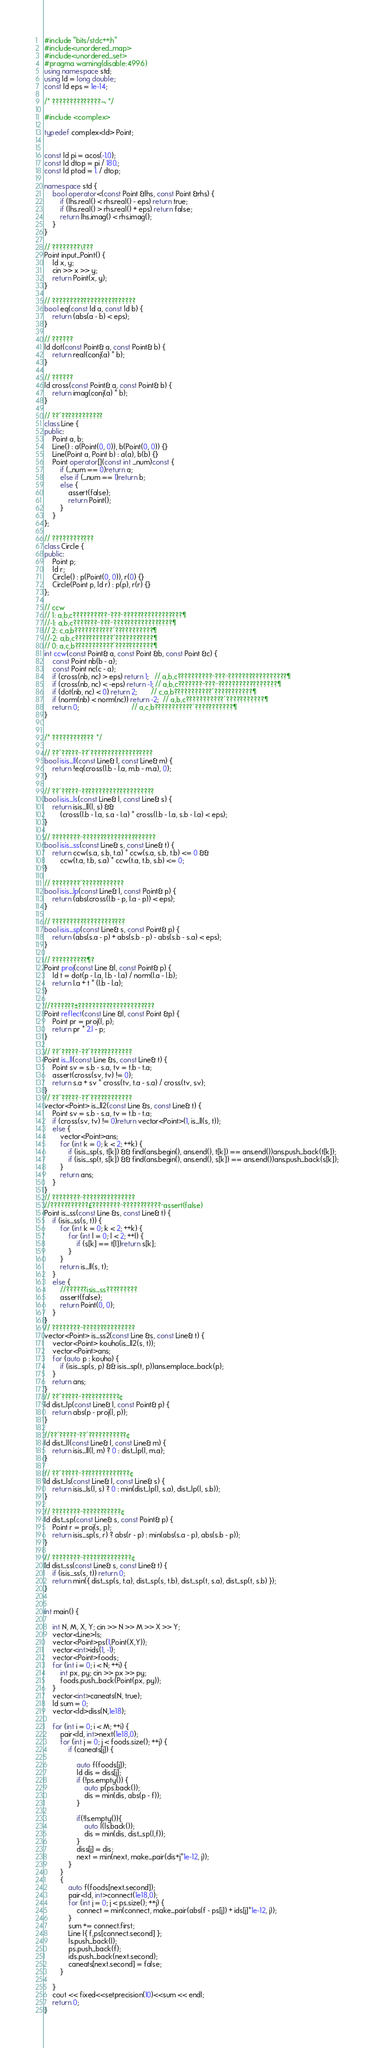Convert code to text. <code><loc_0><loc_0><loc_500><loc_500><_C++_>#include "bits/stdc++.h"
#include<unordered_map>
#include<unordered_set>
#pragma warning(disable:4996)
using namespace std;
using ld = long double;
const ld eps = 1e-14;

/* ??????????????¬ */

#include <complex>

typedef complex<ld> Point;


const ld pi = acos(-1.0);
const ld dtop = pi / 180.;
const ld ptod = 1. / dtop;

namespace std {
	bool operator<(const Point &lhs, const Point &rhs) {
		if (lhs.real() < rhs.real() - eps) return true;
		if (lhs.real() > rhs.real() + eps) return false;
		return lhs.imag() < rhs.imag();
	}
}

// ????????\???
Point input_Point() {
	ld x, y;
	cin >> x >> y;
	return Point(x, y);
}

// ????????????????????????
bool eq(const ld a, const ld b) {
	return (abs(a - b) < eps);
}

// ??????
ld dot(const Point& a, const Point& b) {
	return real(conj(a) * b);
}

// ??????
ld cross(const Point& a, const Point& b) {
	return imag(conj(a) * b);
}

// ??´????????????
class Line {
public:
	Point a, b;
	Line() : a(Point(0, 0)), b(Point(0, 0)) {}
	Line(Point a, Point b) : a(a), b(b) {}
	Point operator[](const int _num)const {
		if (_num == 0)return a;
		else if (_num == 1)return b;
		else {
			assert(false);
			return Point();
		}
	}
};

// ????????????
class Circle {
public:
	Point p;
	ld r;
	Circle() : p(Point(0, 0)), r(0) {}
	Circle(Point p, ld r) : p(p), r(r) {}
};

// ccw
// 1: a,b,c??????????¨???¨?????????????????¶
//-1: a,b,c???????¨???¨?????????????????¶
// 2: c,a,b???????????´???????????¶
//-2: a,b,c???????????´???????????¶
// 0: a,c,b???????????´???????????¶
int ccw(const Point& a, const Point &b, const Point &c) {
	const Point nb(b - a);
	const Point nc(c - a);
	if (cross(nb, nc) > eps) return 1;   // a,b,c??????????¨???¨?????????????????¶
	if (cross(nb, nc) < -eps) return -1; // a,b,c???????¨???¨?????????????????¶
	if (dot(nb, nc) < 0) return 2;       // c,a,b???????????´???????????¶
	if (norm(nb) < norm(nc)) return -2;  // a,b,c???????????´???????????¶
	return 0;                          // a,c,b???????????´???????????¶
}


/* ???????????? */

// ??´?????¨??´??????????????????
bool isis_ll(const Line& l, const Line& m) {
	return !eq(cross(l.b - l.a, m.b - m.a), 0);
}

// ??´?????¨?????????????????????
bool isis_ls(const Line& l, const Line& s) {
	return isis_ll(l, s) &&
		(cross(l.b - l.a, s.a - l.a) * cross(l.b - l.a, s.b - l.a) < eps);
}

// ????????¨?????????????????????
bool isis_ss(const Line& s, const Line& t) {
	return ccw(s.a, s.b, t.a) * ccw(s.a, s.b, t.b) <= 0 &&
		ccw(t.a, t.b, s.a) * ccw(t.a, t.b, s.b) <= 0;
}

// ????????´????????????
bool isis_lp(const Line& l, const Point& p) {
	return (abs(cross(l.b - p, l.a - p)) < eps);
}

// ?????????????????????
bool isis_sp(const Line& s, const Point& p) {
	return (abs(s.a - p) + abs(s.b - p) - abs(s.b - s.a) < eps);
}

// ??????????¶?
Point proj(const Line &l, const Point& p) {
	ld t = dot(p - l.a, l.b - l.a) / norm(l.a - l.b);
	return l.a + t * (l.b - l.a);
}

//???????±??????????????????????
Point reflect(const Line &l, const Point &p) {
	Point pr = proj(l, p);
	return pr * 2.l - p;
}

// ??´?????¨??´????????????
Point is_ll(const Line &s, const Line& t) {
	Point sv = s.b - s.a, tv = t.b - t.a;
	assert(cross(sv, tv) != 0);
	return s.a + sv * cross(tv, t.a - s.a) / cross(tv, sv);
}
// ??´?????¨??´????????????
vector<Point> is_ll2(const Line &s, const Line& t) {
	Point sv = s.b - s.a, tv = t.b - t.a;
	if (cross(sv, tv) != 0)return vector<Point>(1, is_ll(s, t));
	else {
		vector<Point>ans;
		for (int k = 0; k < 2; ++k) {
			if (isis_sp(s, t[k]) && find(ans.begin(), ans.end(), t[k]) == ans.end())ans.push_back(t[k]);
			if (isis_sp(t, s[k]) && find(ans.begin(), ans.end(), s[k]) == ans.end())ans.push_back(s[k]);
		}
		return ans;
	}
}
// ????????¨???????????????
//???????????£????????¨???????????¨assert(false)
Point is_ss(const Line &s, const Line& t) {
	if (isis_ss(s, t)) {
		for (int k = 0; k < 2; ++k) {
			for (int l = 0; l < 2; ++l) {
				if (s[k] == t[l])return s[k];
			}
		}
		return is_ll(s, t);
	}
	else {
		//??????isis_ss?????????
		assert(false);
		return Point(0, 0);
	}
}
// ????????¨???????????????
vector<Point> is_ss2(const Line &s, const Line& t) {
	vector<Point> kouho(is_ll2(s, t));
	vector<Point>ans;
	for (auto p : kouho) {
		if (isis_sp(s, p) && isis_sp(t, p))ans.emplace_back(p);
	}
	return ans;
}
// ??´?????¨???????????¢
ld dist_lp(const Line& l, const Point& p) {
	return abs(p - proj(l, p));
}

//??´?????¨??´???????????¢
ld dist_ll(const Line& l, const Line& m) {
	return isis_ll(l, m) ? 0 : dist_lp(l, m.a);
}

// ??´?????¨??????????????¢
ld dist_ls(const Line& l, const Line& s) {
	return isis_ls(l, s) ? 0 : min(dist_lp(l, s.a), dist_lp(l, s.b));
}

// ????????¨???????????¢
ld dist_sp(const Line& s, const Point& p) {
	Point r = proj(s, p);
	return isis_sp(s, r) ? abs(r - p) : min(abs(s.a - p), abs(s.b - p));
}

// ????????¨??????????????¢
ld dist_ss(const Line& s, const Line& t) {
	if (isis_ss(s, t)) return 0;
	return min({ dist_sp(s, t.a), dist_sp(s, t.b), dist_sp(t, s.a), dist_sp(t, s.b) });
}


int main() {
	
	int N, M, X, Y; cin >> N >> M >> X >> Y;
	vector<Line>ls;
	vector<Point>ps(1,Point(X,Y));
	vector<int>ids(1, -1);
	vector<Point>foods;
	for (int i = 0; i < N; ++i) {
		int px, py; cin >> px >> py;
		foods.push_back(Point(px, py));
	}
	vector<int>caneats(N, true);
	ld sum = 0;
	vector<ld>diss(N,1e18);

	for (int i = 0; i < M; ++i) {
		pair<ld, int>next(1e18,0);
		for (int j = 0; j < foods.size(); ++j) {
			if (caneats[j]) {

				auto f(foods[j]);
				ld dis = diss[j];
				if (!ps.empty()) {
					auto p(ps.back());
					dis = min(dis, abs(p - f));
				}
				
				if(!ls.empty()){
					auto l(ls.back());
					dis = min(dis, dist_sp(l,f));
				}
				diss[j] = dis;
				next = min(next, make_pair(dis+j*1e-12, j));
			}
		} 
		{
			auto f(foods[next.second]);
			pair<ld, int>connect(1e18,0);
			for (int j = 0; j < ps.size(); ++j) {
				connect = min(connect, make_pair(abs(f - ps[j]) + ids[j]*1e-12, j));
			}
			sum += connect.first;
			Line l{ f,ps[connect.second] };
			ls.push_back(l);
			ps.push_back(f);
			ids.push_back(next.second);
			caneats[next.second] = false;
		}
		
	}
	cout << fixed<<setprecision(10)<<sum << endl;
	return 0;
}</code> 